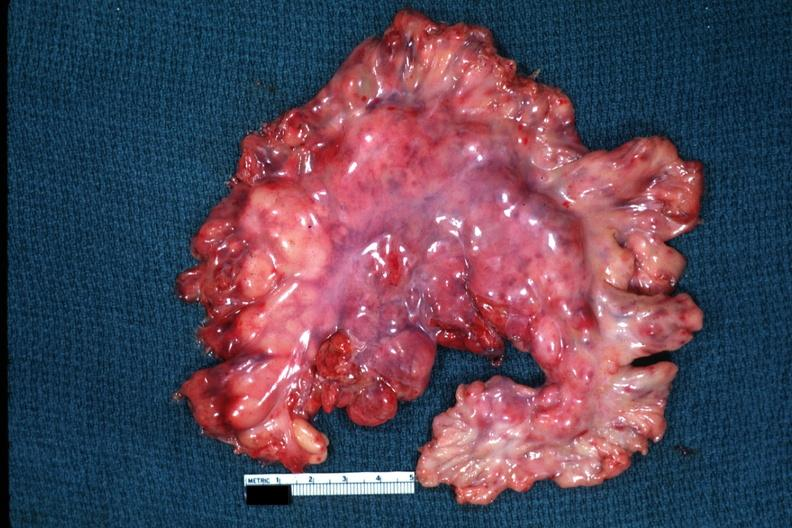does this image show massive node enlargement like a lymphoma?
Answer the question using a single word or phrase. Yes 